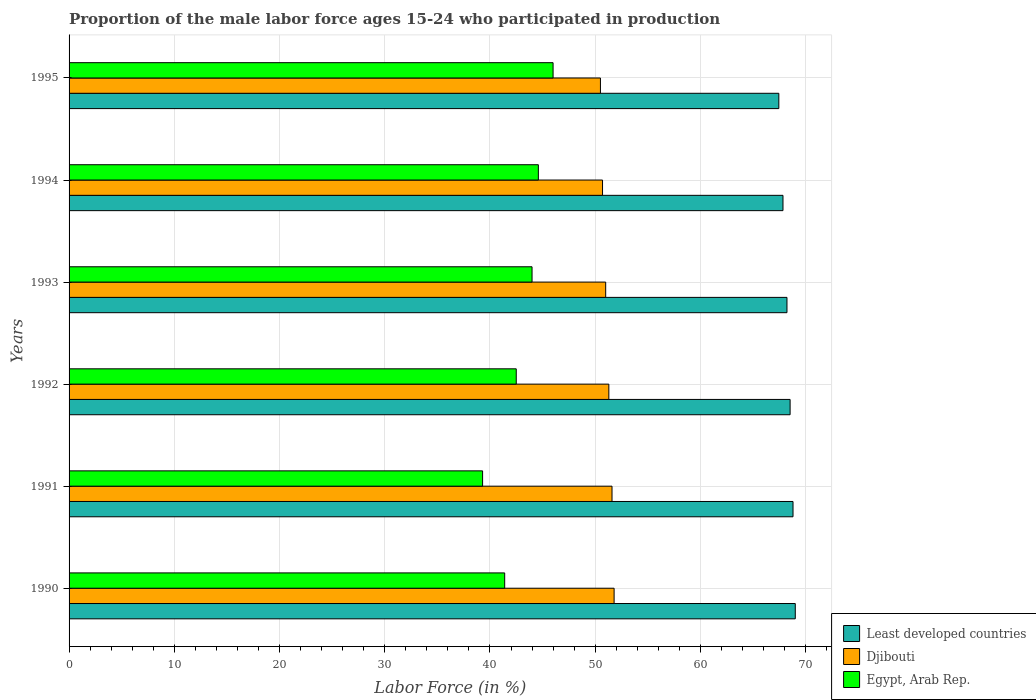Are the number of bars per tick equal to the number of legend labels?
Provide a short and direct response. Yes. Are the number of bars on each tick of the Y-axis equal?
Provide a succinct answer. Yes. How many bars are there on the 2nd tick from the top?
Keep it short and to the point. 3. How many bars are there on the 1st tick from the bottom?
Ensure brevity in your answer.  3. What is the label of the 6th group of bars from the top?
Ensure brevity in your answer.  1990. What is the proportion of the male labor force who participated in production in Egypt, Arab Rep. in 1993?
Offer a very short reply. 44. Across all years, what is the maximum proportion of the male labor force who participated in production in Djibouti?
Your answer should be compact. 51.8. Across all years, what is the minimum proportion of the male labor force who participated in production in Least developed countries?
Ensure brevity in your answer.  67.45. In which year was the proportion of the male labor force who participated in production in Least developed countries maximum?
Ensure brevity in your answer.  1990. What is the total proportion of the male labor force who participated in production in Least developed countries in the graph?
Provide a succinct answer. 409.88. What is the difference between the proportion of the male labor force who participated in production in Egypt, Arab Rep. in 1993 and that in 1994?
Your response must be concise. -0.6. What is the difference between the proportion of the male labor force who participated in production in Egypt, Arab Rep. in 1994 and the proportion of the male labor force who participated in production in Djibouti in 1993?
Ensure brevity in your answer.  -6.4. What is the average proportion of the male labor force who participated in production in Djibouti per year?
Your answer should be very brief. 51.15. In the year 1990, what is the difference between the proportion of the male labor force who participated in production in Djibouti and proportion of the male labor force who participated in production in Egypt, Arab Rep.?
Ensure brevity in your answer.  10.4. What is the ratio of the proportion of the male labor force who participated in production in Least developed countries in 1993 to that in 1994?
Provide a succinct answer. 1.01. What is the difference between the highest and the second highest proportion of the male labor force who participated in production in Djibouti?
Your answer should be very brief. 0.2. What is the difference between the highest and the lowest proportion of the male labor force who participated in production in Least developed countries?
Give a very brief answer. 1.56. Is the sum of the proportion of the male labor force who participated in production in Egypt, Arab Rep. in 1992 and 1995 greater than the maximum proportion of the male labor force who participated in production in Least developed countries across all years?
Offer a terse response. Yes. What does the 1st bar from the top in 1992 represents?
Offer a terse response. Egypt, Arab Rep. What does the 3rd bar from the bottom in 1991 represents?
Give a very brief answer. Egypt, Arab Rep. Are all the bars in the graph horizontal?
Provide a succinct answer. Yes. How many years are there in the graph?
Give a very brief answer. 6. Are the values on the major ticks of X-axis written in scientific E-notation?
Keep it short and to the point. No. Does the graph contain any zero values?
Make the answer very short. No. Does the graph contain grids?
Make the answer very short. Yes. Where does the legend appear in the graph?
Your answer should be compact. Bottom right. How many legend labels are there?
Provide a succinct answer. 3. What is the title of the graph?
Give a very brief answer. Proportion of the male labor force ages 15-24 who participated in production. What is the label or title of the X-axis?
Keep it short and to the point. Labor Force (in %). What is the label or title of the Y-axis?
Ensure brevity in your answer.  Years. What is the Labor Force (in %) of Least developed countries in 1990?
Your answer should be very brief. 69.02. What is the Labor Force (in %) of Djibouti in 1990?
Offer a terse response. 51.8. What is the Labor Force (in %) of Egypt, Arab Rep. in 1990?
Ensure brevity in your answer.  41.4. What is the Labor Force (in %) of Least developed countries in 1991?
Ensure brevity in your answer.  68.8. What is the Labor Force (in %) in Djibouti in 1991?
Make the answer very short. 51.6. What is the Labor Force (in %) in Egypt, Arab Rep. in 1991?
Offer a terse response. 39.3. What is the Labor Force (in %) of Least developed countries in 1992?
Provide a succinct answer. 68.53. What is the Labor Force (in %) of Djibouti in 1992?
Provide a succinct answer. 51.3. What is the Labor Force (in %) in Egypt, Arab Rep. in 1992?
Your answer should be compact. 42.5. What is the Labor Force (in %) in Least developed countries in 1993?
Provide a succinct answer. 68.23. What is the Labor Force (in %) of Least developed countries in 1994?
Keep it short and to the point. 67.85. What is the Labor Force (in %) in Djibouti in 1994?
Give a very brief answer. 50.7. What is the Labor Force (in %) of Egypt, Arab Rep. in 1994?
Offer a very short reply. 44.6. What is the Labor Force (in %) of Least developed countries in 1995?
Your answer should be very brief. 67.45. What is the Labor Force (in %) in Djibouti in 1995?
Your answer should be compact. 50.5. Across all years, what is the maximum Labor Force (in %) in Least developed countries?
Provide a short and direct response. 69.02. Across all years, what is the maximum Labor Force (in %) in Djibouti?
Keep it short and to the point. 51.8. Across all years, what is the minimum Labor Force (in %) in Least developed countries?
Offer a very short reply. 67.45. Across all years, what is the minimum Labor Force (in %) in Djibouti?
Provide a short and direct response. 50.5. Across all years, what is the minimum Labor Force (in %) in Egypt, Arab Rep.?
Your answer should be very brief. 39.3. What is the total Labor Force (in %) in Least developed countries in the graph?
Provide a succinct answer. 409.88. What is the total Labor Force (in %) in Djibouti in the graph?
Make the answer very short. 306.9. What is the total Labor Force (in %) of Egypt, Arab Rep. in the graph?
Your answer should be compact. 257.8. What is the difference between the Labor Force (in %) of Least developed countries in 1990 and that in 1991?
Ensure brevity in your answer.  0.21. What is the difference between the Labor Force (in %) in Djibouti in 1990 and that in 1991?
Your answer should be compact. 0.2. What is the difference between the Labor Force (in %) of Least developed countries in 1990 and that in 1992?
Give a very brief answer. 0.49. What is the difference between the Labor Force (in %) in Egypt, Arab Rep. in 1990 and that in 1992?
Keep it short and to the point. -1.1. What is the difference between the Labor Force (in %) in Least developed countries in 1990 and that in 1993?
Your answer should be compact. 0.79. What is the difference between the Labor Force (in %) of Least developed countries in 1990 and that in 1994?
Provide a succinct answer. 1.17. What is the difference between the Labor Force (in %) of Egypt, Arab Rep. in 1990 and that in 1994?
Your response must be concise. -3.2. What is the difference between the Labor Force (in %) of Least developed countries in 1990 and that in 1995?
Your response must be concise. 1.56. What is the difference between the Labor Force (in %) of Egypt, Arab Rep. in 1990 and that in 1995?
Give a very brief answer. -4.6. What is the difference between the Labor Force (in %) in Least developed countries in 1991 and that in 1992?
Give a very brief answer. 0.28. What is the difference between the Labor Force (in %) of Egypt, Arab Rep. in 1991 and that in 1992?
Ensure brevity in your answer.  -3.2. What is the difference between the Labor Force (in %) in Least developed countries in 1991 and that in 1993?
Offer a very short reply. 0.57. What is the difference between the Labor Force (in %) in Djibouti in 1991 and that in 1993?
Provide a short and direct response. 0.6. What is the difference between the Labor Force (in %) in Least developed countries in 1991 and that in 1994?
Give a very brief answer. 0.95. What is the difference between the Labor Force (in %) of Egypt, Arab Rep. in 1991 and that in 1994?
Your response must be concise. -5.3. What is the difference between the Labor Force (in %) of Least developed countries in 1991 and that in 1995?
Provide a succinct answer. 1.35. What is the difference between the Labor Force (in %) in Djibouti in 1991 and that in 1995?
Your response must be concise. 1.1. What is the difference between the Labor Force (in %) of Least developed countries in 1992 and that in 1993?
Make the answer very short. 0.3. What is the difference between the Labor Force (in %) in Djibouti in 1992 and that in 1993?
Make the answer very short. 0.3. What is the difference between the Labor Force (in %) of Egypt, Arab Rep. in 1992 and that in 1993?
Make the answer very short. -1.5. What is the difference between the Labor Force (in %) in Least developed countries in 1992 and that in 1994?
Your answer should be very brief. 0.68. What is the difference between the Labor Force (in %) in Least developed countries in 1992 and that in 1995?
Your response must be concise. 1.07. What is the difference between the Labor Force (in %) in Djibouti in 1992 and that in 1995?
Make the answer very short. 0.8. What is the difference between the Labor Force (in %) in Least developed countries in 1993 and that in 1994?
Ensure brevity in your answer.  0.38. What is the difference between the Labor Force (in %) in Egypt, Arab Rep. in 1993 and that in 1994?
Your response must be concise. -0.6. What is the difference between the Labor Force (in %) in Least developed countries in 1993 and that in 1995?
Give a very brief answer. 0.77. What is the difference between the Labor Force (in %) in Djibouti in 1993 and that in 1995?
Ensure brevity in your answer.  0.5. What is the difference between the Labor Force (in %) of Least developed countries in 1994 and that in 1995?
Ensure brevity in your answer.  0.4. What is the difference between the Labor Force (in %) in Egypt, Arab Rep. in 1994 and that in 1995?
Offer a very short reply. -1.4. What is the difference between the Labor Force (in %) of Least developed countries in 1990 and the Labor Force (in %) of Djibouti in 1991?
Your response must be concise. 17.42. What is the difference between the Labor Force (in %) of Least developed countries in 1990 and the Labor Force (in %) of Egypt, Arab Rep. in 1991?
Provide a short and direct response. 29.72. What is the difference between the Labor Force (in %) of Djibouti in 1990 and the Labor Force (in %) of Egypt, Arab Rep. in 1991?
Provide a short and direct response. 12.5. What is the difference between the Labor Force (in %) of Least developed countries in 1990 and the Labor Force (in %) of Djibouti in 1992?
Make the answer very short. 17.72. What is the difference between the Labor Force (in %) in Least developed countries in 1990 and the Labor Force (in %) in Egypt, Arab Rep. in 1992?
Give a very brief answer. 26.52. What is the difference between the Labor Force (in %) in Least developed countries in 1990 and the Labor Force (in %) in Djibouti in 1993?
Ensure brevity in your answer.  18.02. What is the difference between the Labor Force (in %) in Least developed countries in 1990 and the Labor Force (in %) in Egypt, Arab Rep. in 1993?
Your answer should be compact. 25.02. What is the difference between the Labor Force (in %) of Djibouti in 1990 and the Labor Force (in %) of Egypt, Arab Rep. in 1993?
Provide a succinct answer. 7.8. What is the difference between the Labor Force (in %) in Least developed countries in 1990 and the Labor Force (in %) in Djibouti in 1994?
Offer a terse response. 18.32. What is the difference between the Labor Force (in %) in Least developed countries in 1990 and the Labor Force (in %) in Egypt, Arab Rep. in 1994?
Your response must be concise. 24.42. What is the difference between the Labor Force (in %) of Djibouti in 1990 and the Labor Force (in %) of Egypt, Arab Rep. in 1994?
Provide a succinct answer. 7.2. What is the difference between the Labor Force (in %) in Least developed countries in 1990 and the Labor Force (in %) in Djibouti in 1995?
Offer a very short reply. 18.52. What is the difference between the Labor Force (in %) of Least developed countries in 1990 and the Labor Force (in %) of Egypt, Arab Rep. in 1995?
Keep it short and to the point. 23.02. What is the difference between the Labor Force (in %) of Djibouti in 1990 and the Labor Force (in %) of Egypt, Arab Rep. in 1995?
Offer a terse response. 5.8. What is the difference between the Labor Force (in %) of Least developed countries in 1991 and the Labor Force (in %) of Djibouti in 1992?
Keep it short and to the point. 17.5. What is the difference between the Labor Force (in %) in Least developed countries in 1991 and the Labor Force (in %) in Egypt, Arab Rep. in 1992?
Keep it short and to the point. 26.3. What is the difference between the Labor Force (in %) of Djibouti in 1991 and the Labor Force (in %) of Egypt, Arab Rep. in 1992?
Keep it short and to the point. 9.1. What is the difference between the Labor Force (in %) of Least developed countries in 1991 and the Labor Force (in %) of Djibouti in 1993?
Your answer should be compact. 17.8. What is the difference between the Labor Force (in %) of Least developed countries in 1991 and the Labor Force (in %) of Egypt, Arab Rep. in 1993?
Offer a very short reply. 24.8. What is the difference between the Labor Force (in %) in Least developed countries in 1991 and the Labor Force (in %) in Djibouti in 1994?
Provide a succinct answer. 18.1. What is the difference between the Labor Force (in %) of Least developed countries in 1991 and the Labor Force (in %) of Egypt, Arab Rep. in 1994?
Keep it short and to the point. 24.2. What is the difference between the Labor Force (in %) of Djibouti in 1991 and the Labor Force (in %) of Egypt, Arab Rep. in 1994?
Make the answer very short. 7. What is the difference between the Labor Force (in %) in Least developed countries in 1991 and the Labor Force (in %) in Djibouti in 1995?
Make the answer very short. 18.3. What is the difference between the Labor Force (in %) of Least developed countries in 1991 and the Labor Force (in %) of Egypt, Arab Rep. in 1995?
Make the answer very short. 22.8. What is the difference between the Labor Force (in %) of Djibouti in 1991 and the Labor Force (in %) of Egypt, Arab Rep. in 1995?
Give a very brief answer. 5.6. What is the difference between the Labor Force (in %) of Least developed countries in 1992 and the Labor Force (in %) of Djibouti in 1993?
Offer a very short reply. 17.53. What is the difference between the Labor Force (in %) of Least developed countries in 1992 and the Labor Force (in %) of Egypt, Arab Rep. in 1993?
Offer a terse response. 24.53. What is the difference between the Labor Force (in %) of Least developed countries in 1992 and the Labor Force (in %) of Djibouti in 1994?
Provide a succinct answer. 17.83. What is the difference between the Labor Force (in %) of Least developed countries in 1992 and the Labor Force (in %) of Egypt, Arab Rep. in 1994?
Offer a terse response. 23.93. What is the difference between the Labor Force (in %) of Djibouti in 1992 and the Labor Force (in %) of Egypt, Arab Rep. in 1994?
Ensure brevity in your answer.  6.7. What is the difference between the Labor Force (in %) in Least developed countries in 1992 and the Labor Force (in %) in Djibouti in 1995?
Provide a short and direct response. 18.03. What is the difference between the Labor Force (in %) of Least developed countries in 1992 and the Labor Force (in %) of Egypt, Arab Rep. in 1995?
Provide a succinct answer. 22.53. What is the difference between the Labor Force (in %) of Djibouti in 1992 and the Labor Force (in %) of Egypt, Arab Rep. in 1995?
Offer a terse response. 5.3. What is the difference between the Labor Force (in %) in Least developed countries in 1993 and the Labor Force (in %) in Djibouti in 1994?
Your answer should be compact. 17.53. What is the difference between the Labor Force (in %) in Least developed countries in 1993 and the Labor Force (in %) in Egypt, Arab Rep. in 1994?
Your answer should be very brief. 23.63. What is the difference between the Labor Force (in %) of Least developed countries in 1993 and the Labor Force (in %) of Djibouti in 1995?
Offer a terse response. 17.73. What is the difference between the Labor Force (in %) of Least developed countries in 1993 and the Labor Force (in %) of Egypt, Arab Rep. in 1995?
Offer a very short reply. 22.23. What is the difference between the Labor Force (in %) of Least developed countries in 1994 and the Labor Force (in %) of Djibouti in 1995?
Make the answer very short. 17.35. What is the difference between the Labor Force (in %) in Least developed countries in 1994 and the Labor Force (in %) in Egypt, Arab Rep. in 1995?
Your answer should be compact. 21.85. What is the average Labor Force (in %) of Least developed countries per year?
Provide a short and direct response. 68.31. What is the average Labor Force (in %) in Djibouti per year?
Give a very brief answer. 51.15. What is the average Labor Force (in %) of Egypt, Arab Rep. per year?
Provide a short and direct response. 42.97. In the year 1990, what is the difference between the Labor Force (in %) of Least developed countries and Labor Force (in %) of Djibouti?
Your response must be concise. 17.22. In the year 1990, what is the difference between the Labor Force (in %) in Least developed countries and Labor Force (in %) in Egypt, Arab Rep.?
Your response must be concise. 27.62. In the year 1990, what is the difference between the Labor Force (in %) of Djibouti and Labor Force (in %) of Egypt, Arab Rep.?
Your answer should be compact. 10.4. In the year 1991, what is the difference between the Labor Force (in %) of Least developed countries and Labor Force (in %) of Djibouti?
Give a very brief answer. 17.2. In the year 1991, what is the difference between the Labor Force (in %) in Least developed countries and Labor Force (in %) in Egypt, Arab Rep.?
Provide a short and direct response. 29.5. In the year 1991, what is the difference between the Labor Force (in %) of Djibouti and Labor Force (in %) of Egypt, Arab Rep.?
Offer a very short reply. 12.3. In the year 1992, what is the difference between the Labor Force (in %) in Least developed countries and Labor Force (in %) in Djibouti?
Offer a terse response. 17.23. In the year 1992, what is the difference between the Labor Force (in %) in Least developed countries and Labor Force (in %) in Egypt, Arab Rep.?
Give a very brief answer. 26.03. In the year 1992, what is the difference between the Labor Force (in %) of Djibouti and Labor Force (in %) of Egypt, Arab Rep.?
Your answer should be very brief. 8.8. In the year 1993, what is the difference between the Labor Force (in %) in Least developed countries and Labor Force (in %) in Djibouti?
Keep it short and to the point. 17.23. In the year 1993, what is the difference between the Labor Force (in %) of Least developed countries and Labor Force (in %) of Egypt, Arab Rep.?
Ensure brevity in your answer.  24.23. In the year 1993, what is the difference between the Labor Force (in %) of Djibouti and Labor Force (in %) of Egypt, Arab Rep.?
Provide a short and direct response. 7. In the year 1994, what is the difference between the Labor Force (in %) in Least developed countries and Labor Force (in %) in Djibouti?
Your response must be concise. 17.15. In the year 1994, what is the difference between the Labor Force (in %) in Least developed countries and Labor Force (in %) in Egypt, Arab Rep.?
Provide a succinct answer. 23.25. In the year 1994, what is the difference between the Labor Force (in %) of Djibouti and Labor Force (in %) of Egypt, Arab Rep.?
Offer a terse response. 6.1. In the year 1995, what is the difference between the Labor Force (in %) in Least developed countries and Labor Force (in %) in Djibouti?
Keep it short and to the point. 16.95. In the year 1995, what is the difference between the Labor Force (in %) in Least developed countries and Labor Force (in %) in Egypt, Arab Rep.?
Ensure brevity in your answer.  21.45. What is the ratio of the Labor Force (in %) in Djibouti in 1990 to that in 1991?
Offer a very short reply. 1. What is the ratio of the Labor Force (in %) of Egypt, Arab Rep. in 1990 to that in 1991?
Provide a short and direct response. 1.05. What is the ratio of the Labor Force (in %) in Djibouti in 1990 to that in 1992?
Provide a succinct answer. 1.01. What is the ratio of the Labor Force (in %) of Egypt, Arab Rep. in 1990 to that in 1992?
Offer a very short reply. 0.97. What is the ratio of the Labor Force (in %) in Least developed countries in 1990 to that in 1993?
Provide a short and direct response. 1.01. What is the ratio of the Labor Force (in %) in Djibouti in 1990 to that in 1993?
Ensure brevity in your answer.  1.02. What is the ratio of the Labor Force (in %) in Egypt, Arab Rep. in 1990 to that in 1993?
Provide a short and direct response. 0.94. What is the ratio of the Labor Force (in %) of Least developed countries in 1990 to that in 1994?
Your response must be concise. 1.02. What is the ratio of the Labor Force (in %) in Djibouti in 1990 to that in 1994?
Offer a terse response. 1.02. What is the ratio of the Labor Force (in %) in Egypt, Arab Rep. in 1990 to that in 1994?
Offer a very short reply. 0.93. What is the ratio of the Labor Force (in %) of Least developed countries in 1990 to that in 1995?
Keep it short and to the point. 1.02. What is the ratio of the Labor Force (in %) in Djibouti in 1990 to that in 1995?
Your answer should be compact. 1.03. What is the ratio of the Labor Force (in %) of Least developed countries in 1991 to that in 1992?
Keep it short and to the point. 1. What is the ratio of the Labor Force (in %) in Djibouti in 1991 to that in 1992?
Offer a terse response. 1.01. What is the ratio of the Labor Force (in %) in Egypt, Arab Rep. in 1991 to that in 1992?
Offer a very short reply. 0.92. What is the ratio of the Labor Force (in %) in Least developed countries in 1991 to that in 1993?
Keep it short and to the point. 1.01. What is the ratio of the Labor Force (in %) of Djibouti in 1991 to that in 1993?
Give a very brief answer. 1.01. What is the ratio of the Labor Force (in %) in Egypt, Arab Rep. in 1991 to that in 1993?
Offer a terse response. 0.89. What is the ratio of the Labor Force (in %) of Least developed countries in 1991 to that in 1994?
Provide a short and direct response. 1.01. What is the ratio of the Labor Force (in %) in Djibouti in 1991 to that in 1994?
Your response must be concise. 1.02. What is the ratio of the Labor Force (in %) of Egypt, Arab Rep. in 1991 to that in 1994?
Give a very brief answer. 0.88. What is the ratio of the Labor Force (in %) in Djibouti in 1991 to that in 1995?
Offer a terse response. 1.02. What is the ratio of the Labor Force (in %) of Egypt, Arab Rep. in 1991 to that in 1995?
Your response must be concise. 0.85. What is the ratio of the Labor Force (in %) of Djibouti in 1992 to that in 1993?
Give a very brief answer. 1.01. What is the ratio of the Labor Force (in %) of Egypt, Arab Rep. in 1992 to that in 1993?
Your response must be concise. 0.97. What is the ratio of the Labor Force (in %) of Djibouti in 1992 to that in 1994?
Make the answer very short. 1.01. What is the ratio of the Labor Force (in %) of Egypt, Arab Rep. in 1992 to that in 1994?
Your answer should be compact. 0.95. What is the ratio of the Labor Force (in %) of Least developed countries in 1992 to that in 1995?
Offer a terse response. 1.02. What is the ratio of the Labor Force (in %) of Djibouti in 1992 to that in 1995?
Ensure brevity in your answer.  1.02. What is the ratio of the Labor Force (in %) in Egypt, Arab Rep. in 1992 to that in 1995?
Provide a short and direct response. 0.92. What is the ratio of the Labor Force (in %) of Least developed countries in 1993 to that in 1994?
Make the answer very short. 1.01. What is the ratio of the Labor Force (in %) in Djibouti in 1993 to that in 1994?
Offer a very short reply. 1.01. What is the ratio of the Labor Force (in %) of Egypt, Arab Rep. in 1993 to that in 1994?
Make the answer very short. 0.99. What is the ratio of the Labor Force (in %) of Least developed countries in 1993 to that in 1995?
Make the answer very short. 1.01. What is the ratio of the Labor Force (in %) in Djibouti in 1993 to that in 1995?
Give a very brief answer. 1.01. What is the ratio of the Labor Force (in %) of Egypt, Arab Rep. in 1993 to that in 1995?
Offer a very short reply. 0.96. What is the ratio of the Labor Force (in %) in Least developed countries in 1994 to that in 1995?
Ensure brevity in your answer.  1.01. What is the ratio of the Labor Force (in %) of Egypt, Arab Rep. in 1994 to that in 1995?
Give a very brief answer. 0.97. What is the difference between the highest and the second highest Labor Force (in %) of Least developed countries?
Keep it short and to the point. 0.21. What is the difference between the highest and the second highest Labor Force (in %) in Egypt, Arab Rep.?
Provide a short and direct response. 1.4. What is the difference between the highest and the lowest Labor Force (in %) of Least developed countries?
Offer a very short reply. 1.56. What is the difference between the highest and the lowest Labor Force (in %) of Djibouti?
Offer a terse response. 1.3. 